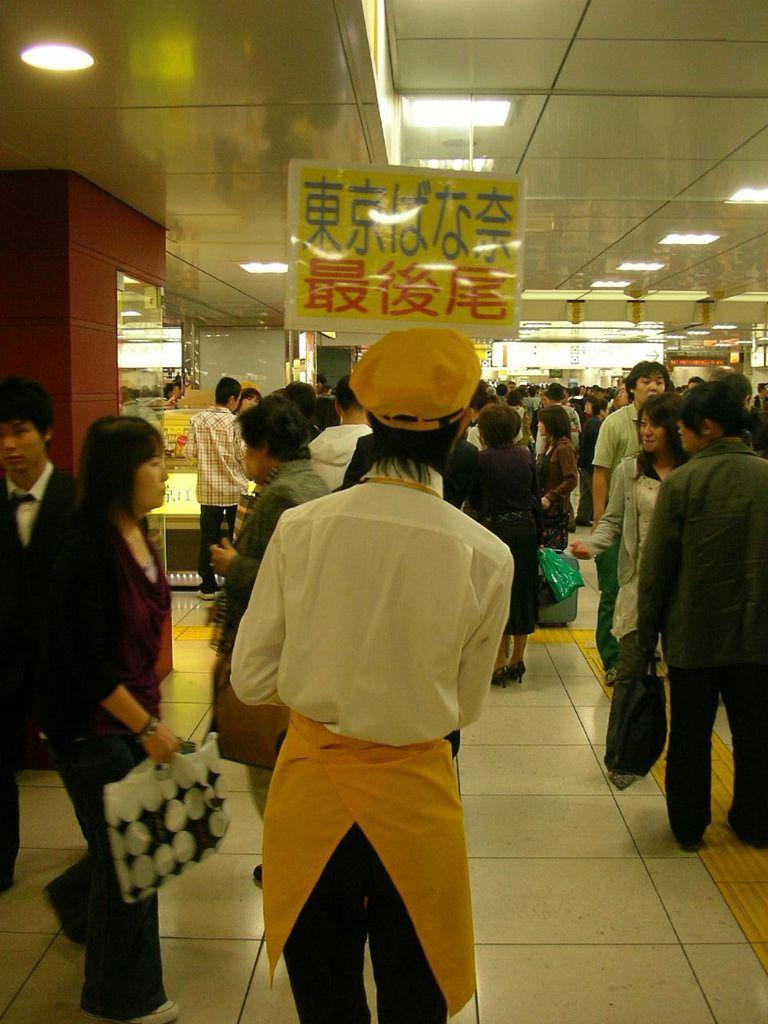What are the people in the image doing? The people in the image are standing on the floor. What can be seen at the top of the image? There are lights visible at the top of the image. What object is present in the image? There is a board in the image. What is visible in the background of the image? There are shops in the background of the image. What type of bells can be heard ringing in the image? There are no bells present in the image, and therefore no sound can be heard. 